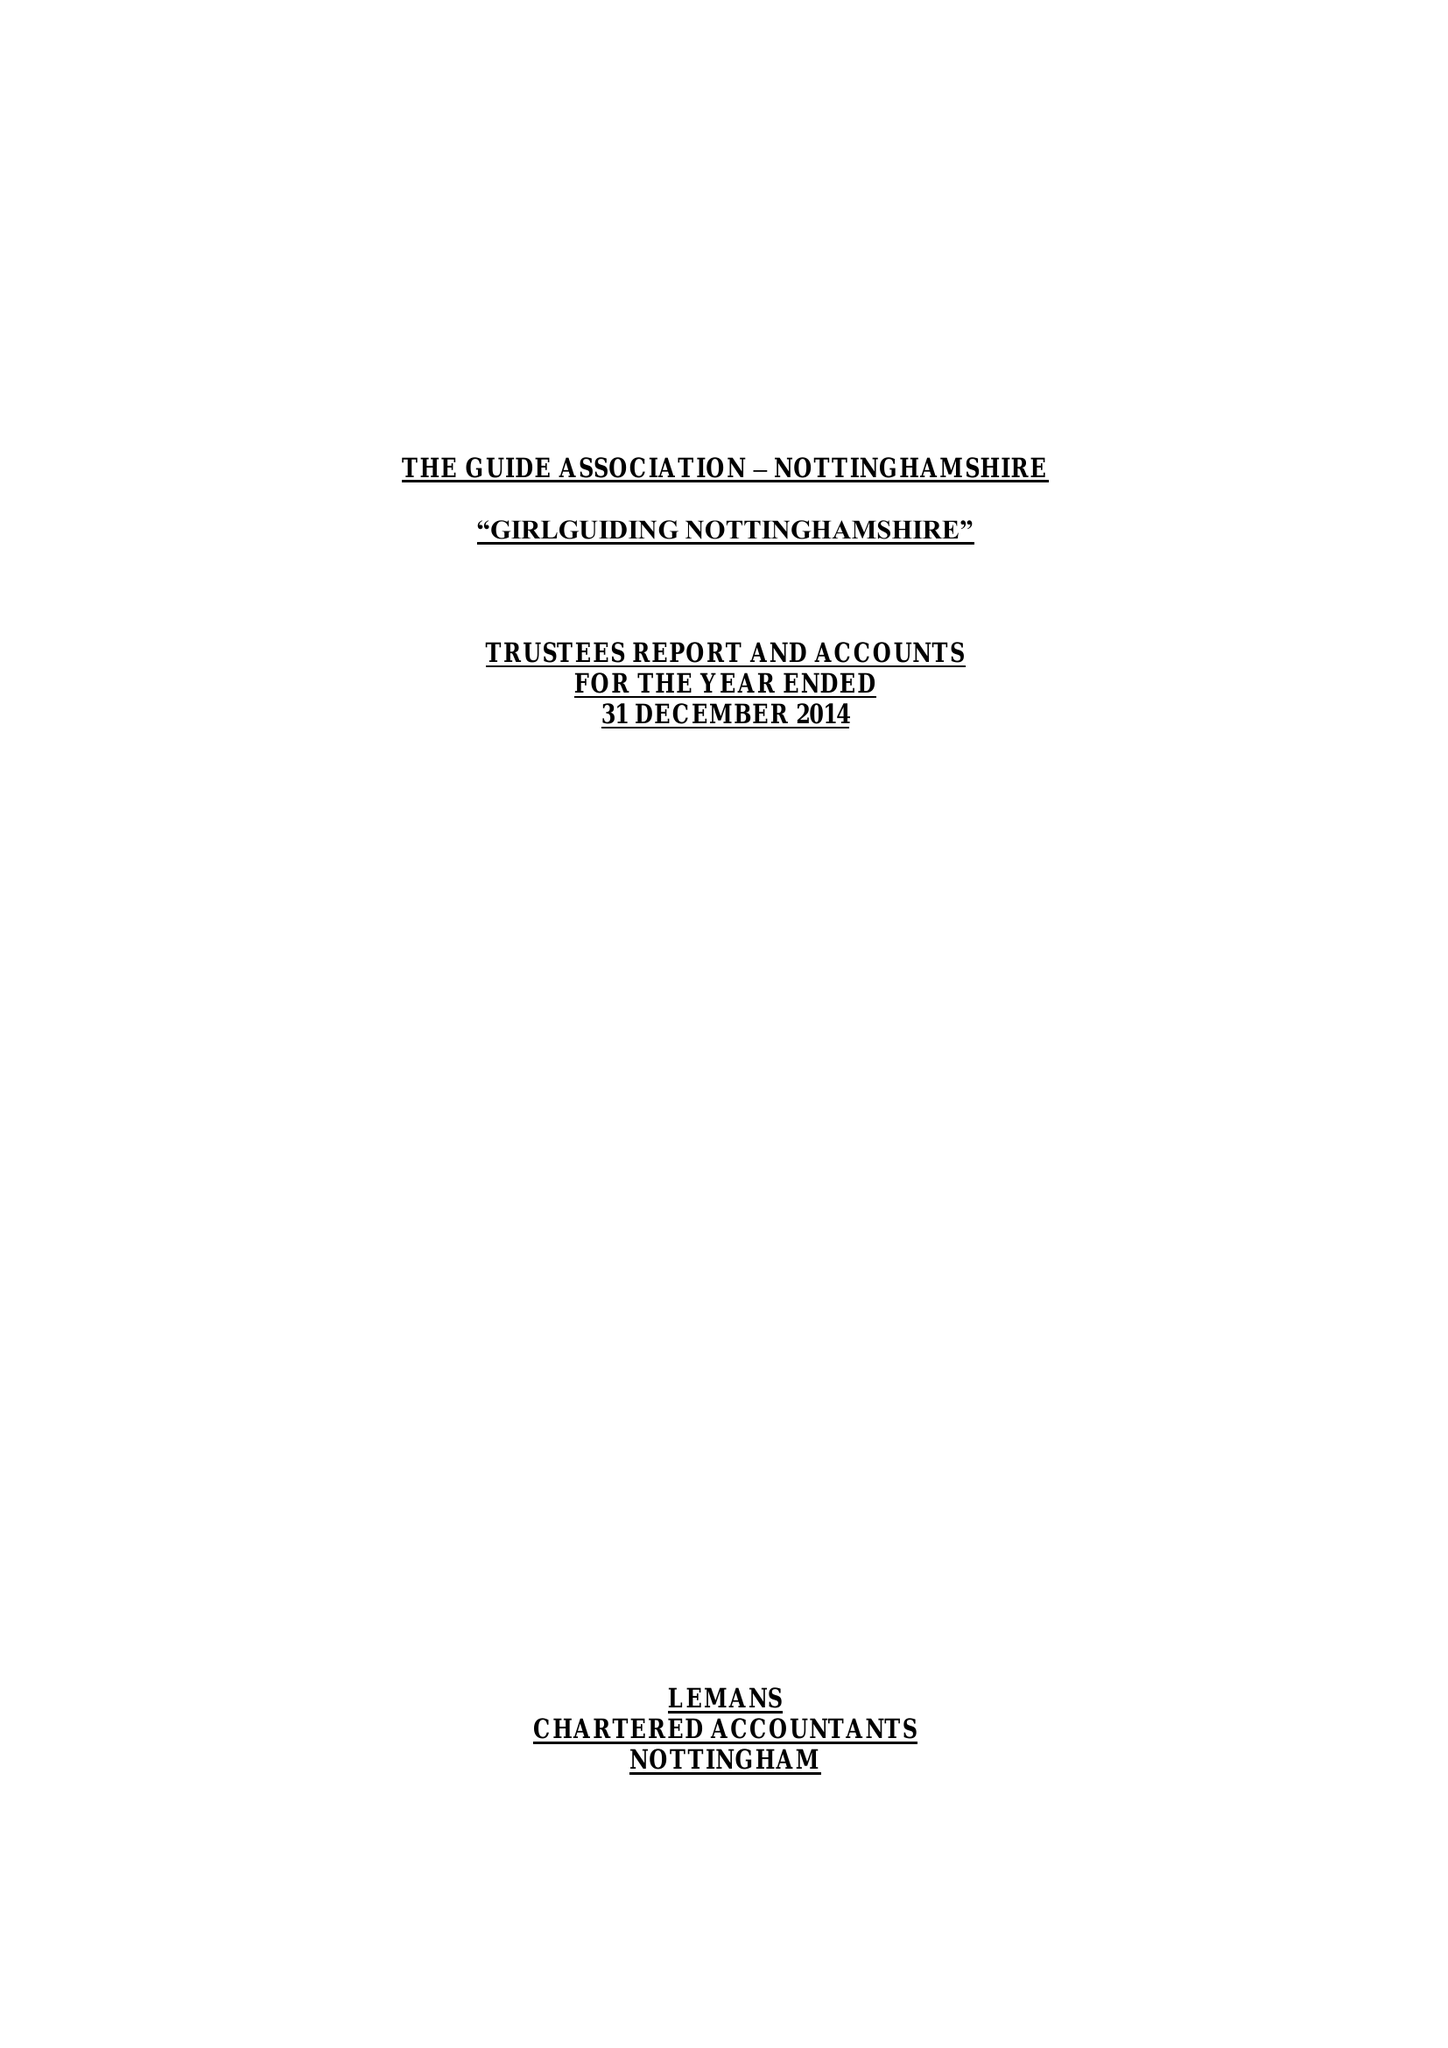What is the value for the address__post_town?
Answer the question using a single word or phrase. NOTTINGHAM 